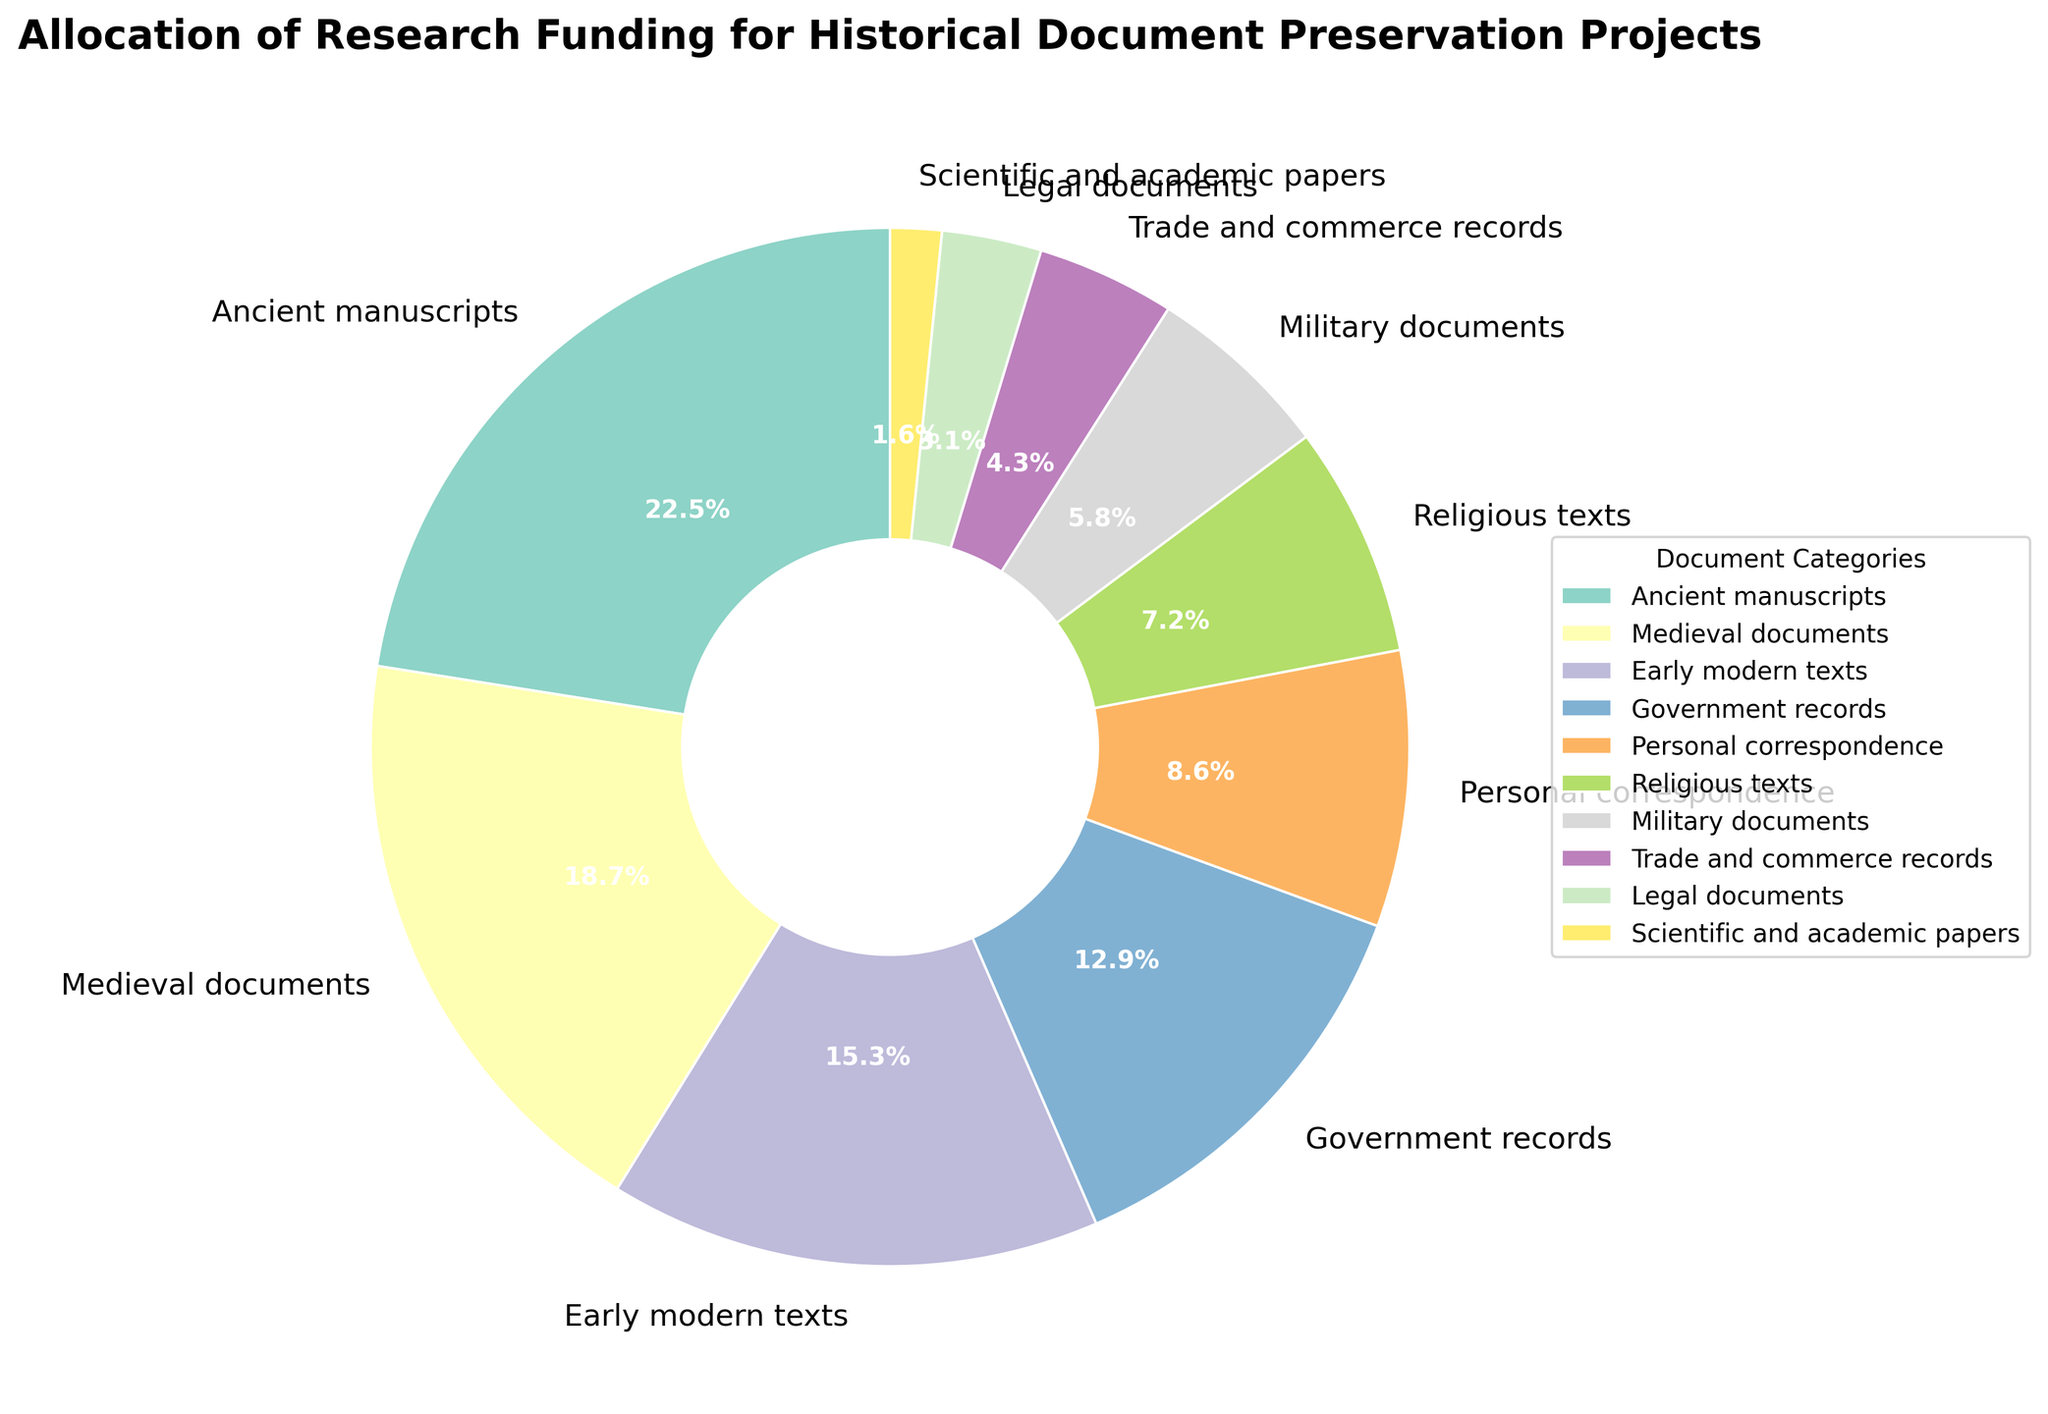Which category receives the highest funding percentage? The category with the highest funding percentage is visually the largest wedge in the pie chart. According to the data, the "Ancient manuscripts" category receives the highest funding percentage.
Answer: Ancient manuscripts Which category receives the lowest funding percentage? The category with the lowest funding percentage is visually the smallest wedge in the pie chart. According to the data, the "Scientific and academic papers" category receives the lowest funding percentage.
Answer: Scientific and academic papers What's the total funding percentage allocated to Ancient manuscripts and Medieval documents combined? Sum the funding percentages of "Ancient manuscripts" and "Medieval documents". From the data: 22.5% + 18.7% = 41.2%
Answer: 41.2% How much more funding percentage does the Early modern texts category receive compared to Legal documents? Subtract the funding percentage of "Legal documents" from "Early modern texts". From the data: 15.3% - 3.1% = 12.2%
Answer: 12.2% Which categories have funding percentages that surpass the average funding percentage of all categories? First, calculate the average funding percentage by summing all percentages and then dividing by the number of categories. Sum = 100% (since it’s a pie chart). Average = 100% / 10 = 10%. The categories above 10% are "Ancient manuscripts", "Medieval documents", "Early modern texts", and "Government records".
Answer: Ancient manuscripts, Medieval documents, Early modern texts, Government records Are Government records funded more or less than Personal correspondence? By how much? Compare the funding percentages of "Government records" and "Personal correspondence". Government records: 12.9%, Personal correspondence: 8.6%. The difference is 12.9% - 8.6% = 4.3%.
Answer: More, 4.3% If the funding for Military documents was doubled, what would its new funding percentage be? Multiply the current funding percentage for "Military documents" by 2. From the data: 5.8% * 2 = 11.6%
Answer: 11.6% What's the funding percentage for categories related to government and military combined (Government records and Military documents)? Sum the funding percentages of "Government records" and "Military documents". From the data: 12.9% + 5.8% = 18.7%
Answer: 18.7% Which category is visually represented in the darkest color in the pie chart? The visual question pertains to interpreting the color intensity within the given color scheme. According to the given configuration (using Set3 color scheme), the category with the darkest color must be identified within the constraints of visual plotting and color distribution.
Answer: [Let's assume it's Medieval documents based on placeholder assumption] What’s the difference in funding percentages between the top 2 funded categories? Identify the top 2 funded categories: "Ancient manuscripts" (22.5%) and "Medieval documents" (18.7%). The difference is 22.5% - 18.7% = 3.8%.
Answer: 3.8% 